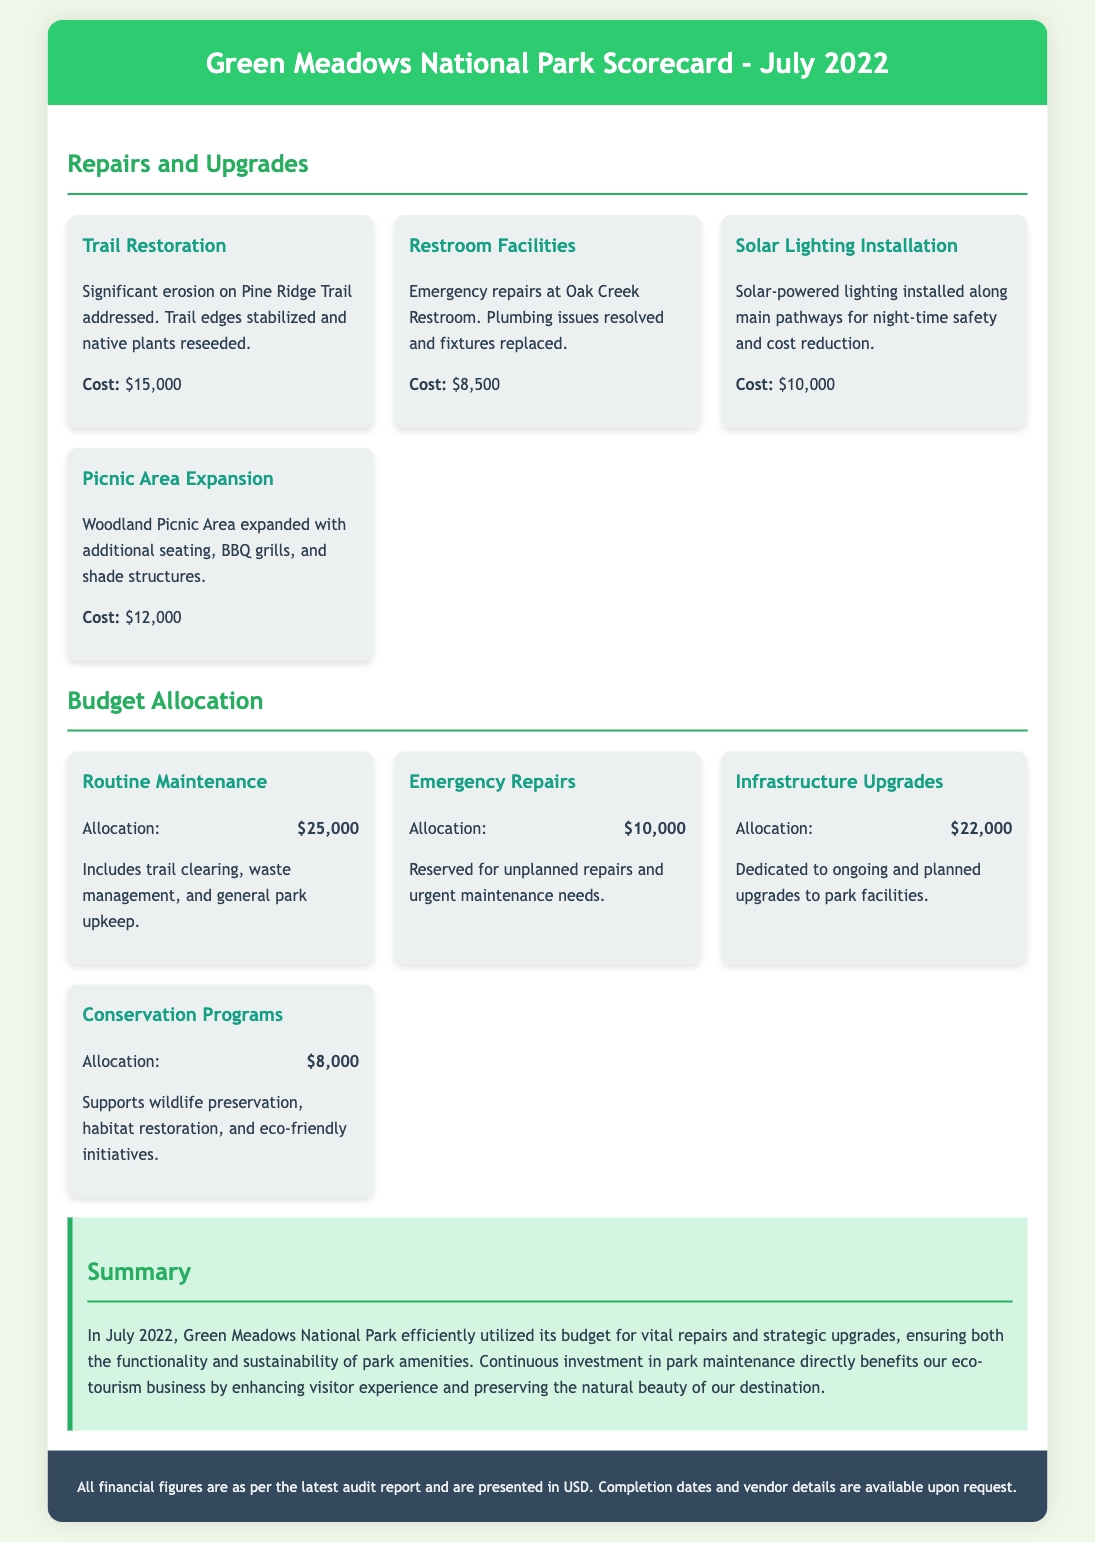what is the cost of Trail Restoration? The cost associated with the Trail Restoration project is listed as $15,000 in the document.
Answer: $15,000 how much was allocated for Routine Maintenance? The document specifies that the allocation for Routine Maintenance is $25,000.
Answer: $25,000 what type of lighting was installed along main pathways? The document mentions that solar-powered lighting was installed for night-time safety.
Answer: Solar-powered lighting how much was spent on Emergency Repairs? According to the document, the expenditure for Emergency Repairs was $10,000.
Answer: $10,000 what is the total budget allocated for Infrastructure Upgrades? The document states that $22,000 was allocated specifically for Infrastructure Upgrades.
Answer: $22,000 why is continuous investment in park maintenance important for eco-tourism? The summary notes that investment enhances visitor experience and preserves natural beauty, which is vital for eco-tourism.
Answer: Enhances visitor experience and preserves natural beauty what was the main purpose of the Solar Lighting Installation project? The document describes the purpose of installing solar lighting as enhancing night-time safety and reducing costs.
Answer: Night-time safety and cost reduction how much money is dedicated to Conservation Programs? The document allocates $8,000 for Conservation Programs.
Answer: $8,000 what additional features were added in the Picnic Area Expansion? The document lists additional seating, BBQ grills, and shade structures as new features in the expanded Picnic Area.
Answer: Additional seating, BBQ grills, and shade structures 